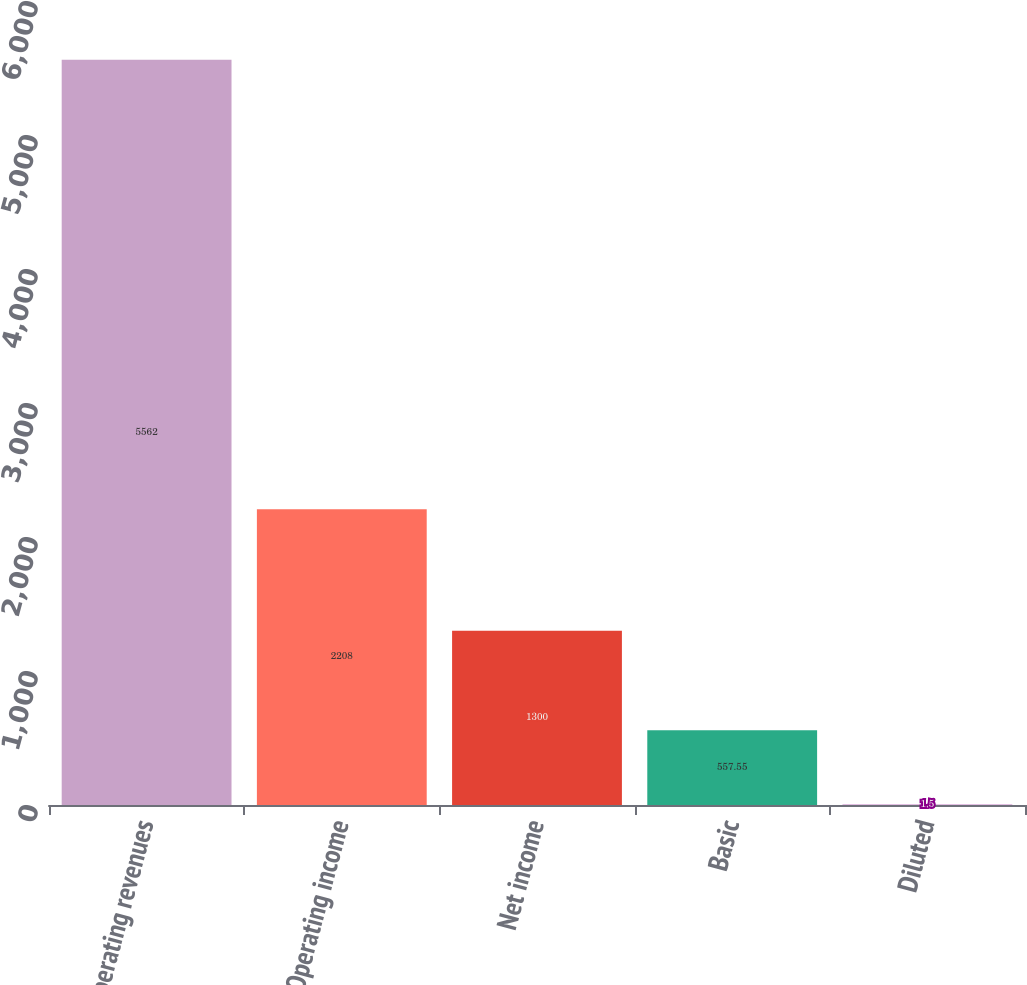Convert chart to OTSL. <chart><loc_0><loc_0><loc_500><loc_500><bar_chart><fcel>Operating revenues<fcel>Operating income<fcel>Net income<fcel>Basic<fcel>Diluted<nl><fcel>5562<fcel>2208<fcel>1300<fcel>557.55<fcel>1.5<nl></chart> 